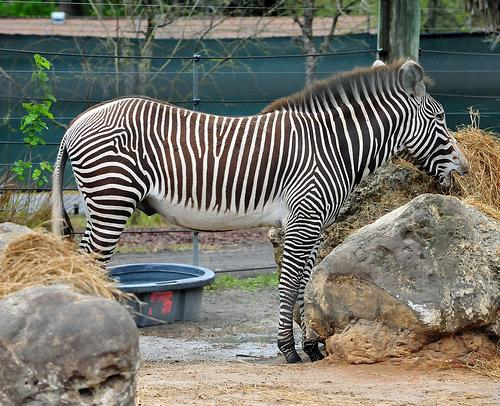Describe the environment where the zebra is situated. A captive zebra stands in an area surrounded by large rocks, a small plant, a wooden post, a fence, and a blue plastic trash bin. Highlight the zebra's physical features, including its mouth and legs. The zebra has a distinct brown and white pattern, stripes on its body, legs and tail, hay in its mouth, and it's standing on all four legs. Narrate the scenario with a focus on the zebra's eating habits. The brown and white striped zebra has a hefty mouthful of hay, and is eating joyously next to a large rocky formation. Comment on the zebra's appearance in relation to its environment. The contrast between the zebra's brown and white stripes and the rocks, blue bin, and plant in its surroundings highlights its captivating presence. Mention the prominent animal in the picture and its action. The zebra, having unique brown and white stripes, is consuming some hay next to a massive rock. Compile the list of objects and details found in the image, without focusing on the zebra. Blue bin, large rock, gray rock, hay stack, wooden post, small plant, cable on fence, marks resembling a face, green leaf, building. Write about the position of the zebra in relation to its surroundings. The zebra stands between two large rocks, with a blue plastic bin nearby, and is close to a fence with cable. Provide a brief summary of the main scene in the image. A zebra with stripes is eating hay next to a large rock, with a blue plastic bin and small green plant nearby, while in captivity. Identify the significant elements present in the image's background. In the background, there is a wooden post, building, and large gray rock as well as a stack of hay on another rock. Express your observation of the zebra in the form of an assumption. I assume that a zebra, which is in captivity and has distinctive stripes, is relishing its meal of hay next to a large boulder. 